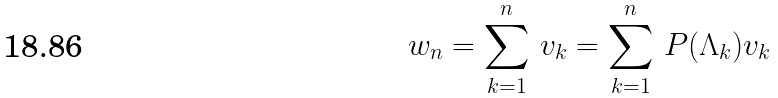Convert formula to latex. <formula><loc_0><loc_0><loc_500><loc_500>w _ { n } = \sum _ { k = 1 } ^ { n } \, v _ { k } = \sum _ { k = 1 } ^ { n } \, P ( \Lambda _ { k } ) v _ { k }</formula> 